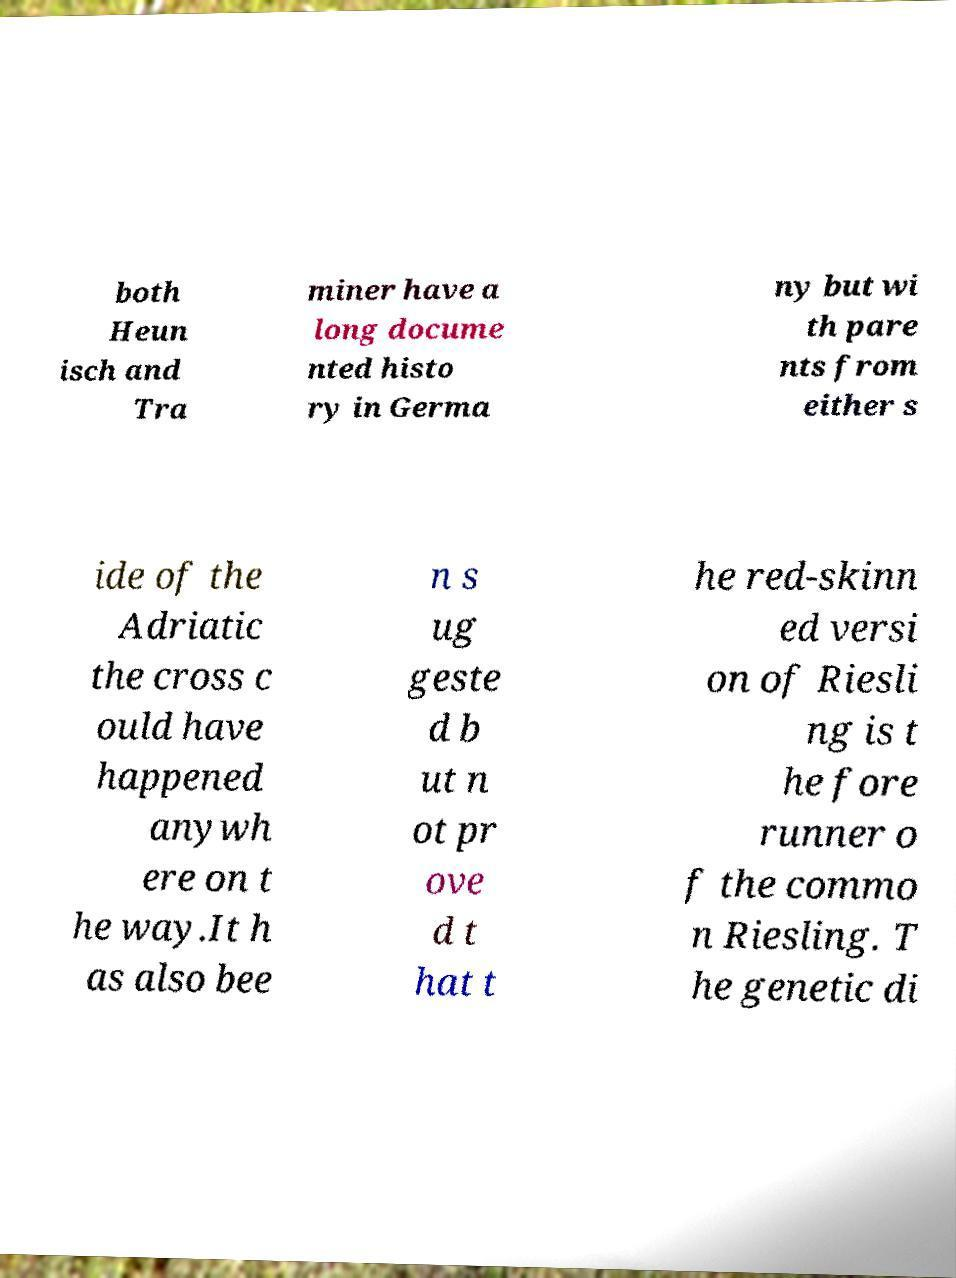Can you accurately transcribe the text from the provided image for me? both Heun isch and Tra miner have a long docume nted histo ry in Germa ny but wi th pare nts from either s ide of the Adriatic the cross c ould have happened anywh ere on t he way.It h as also bee n s ug geste d b ut n ot pr ove d t hat t he red-skinn ed versi on of Riesli ng is t he fore runner o f the commo n Riesling. T he genetic di 